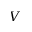Convert formula to latex. <formula><loc_0><loc_0><loc_500><loc_500>V</formula> 